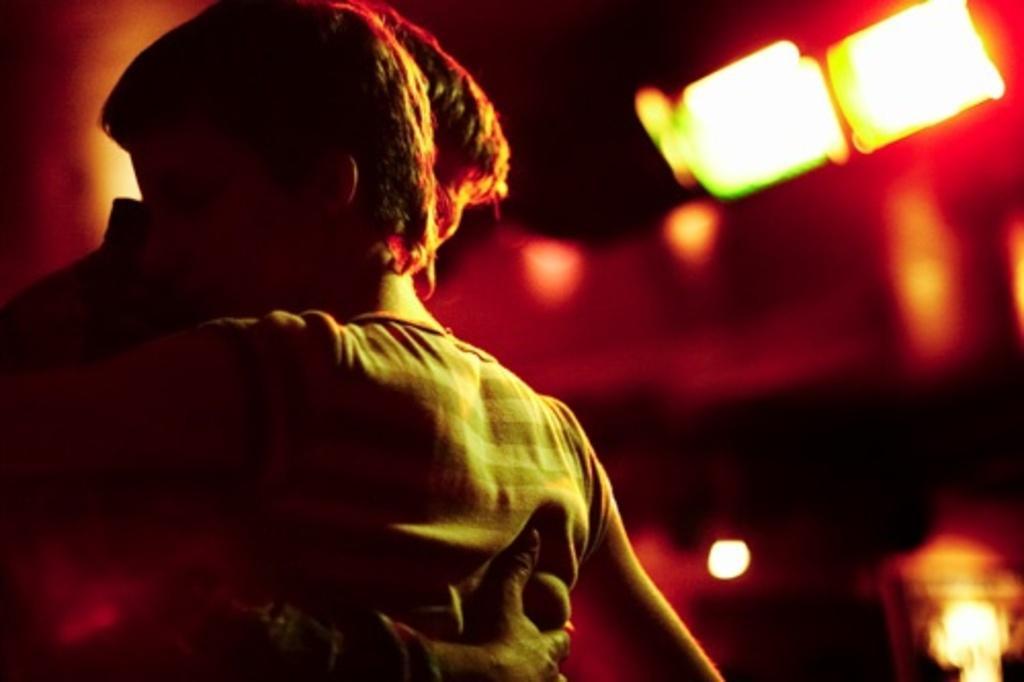Can you describe this image briefly? In the picture I can see two persons hugging each other and there are few lights in the background. 